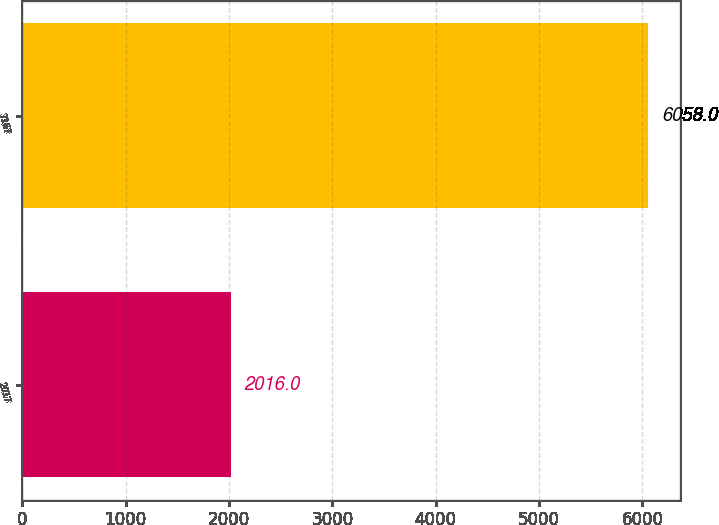Convert chart to OTSL. <chart><loc_0><loc_0><loc_500><loc_500><bar_chart><fcel>2017<fcel>7167<nl><fcel>2016<fcel>6058<nl></chart> 